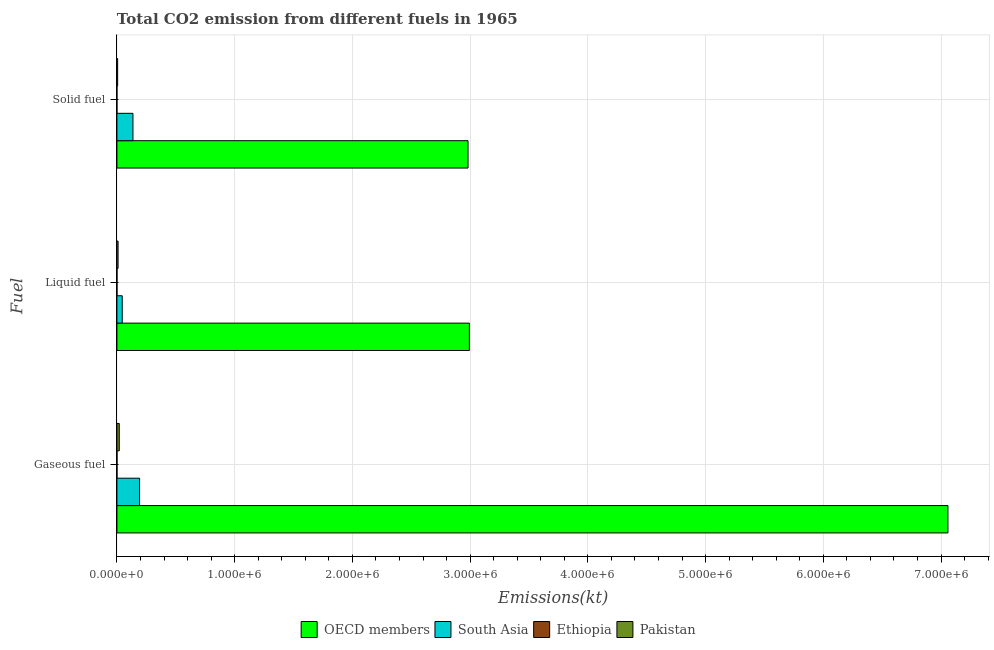How many groups of bars are there?
Offer a very short reply. 3. Are the number of bars per tick equal to the number of legend labels?
Provide a short and direct response. Yes. How many bars are there on the 2nd tick from the bottom?
Your response must be concise. 4. What is the label of the 3rd group of bars from the top?
Offer a terse response. Gaseous fuel. What is the amount of co2 emissions from liquid fuel in Pakistan?
Make the answer very short. 9787.22. Across all countries, what is the maximum amount of co2 emissions from liquid fuel?
Give a very brief answer. 2.99e+06. Across all countries, what is the minimum amount of co2 emissions from liquid fuel?
Offer a terse response. 575.72. In which country was the amount of co2 emissions from liquid fuel minimum?
Give a very brief answer. Ethiopia. What is the total amount of co2 emissions from liquid fuel in the graph?
Your response must be concise. 3.05e+06. What is the difference between the amount of co2 emissions from liquid fuel in Pakistan and that in OECD members?
Offer a very short reply. -2.98e+06. What is the difference between the amount of co2 emissions from liquid fuel in South Asia and the amount of co2 emissions from gaseous fuel in Pakistan?
Provide a short and direct response. 2.51e+04. What is the average amount of co2 emissions from solid fuel per country?
Make the answer very short. 7.81e+05. What is the difference between the amount of co2 emissions from gaseous fuel and amount of co2 emissions from liquid fuel in South Asia?
Your response must be concise. 1.48e+05. In how many countries, is the amount of co2 emissions from gaseous fuel greater than 1200000 kt?
Ensure brevity in your answer.  1. What is the ratio of the amount of co2 emissions from gaseous fuel in OECD members to that in Ethiopia?
Keep it short and to the point. 1.09e+04. What is the difference between the highest and the second highest amount of co2 emissions from solid fuel?
Offer a very short reply. 2.85e+06. What is the difference between the highest and the lowest amount of co2 emissions from solid fuel?
Give a very brief answer. 2.98e+06. What does the 1st bar from the top in Gaseous fuel represents?
Give a very brief answer. Pakistan. What does the 3rd bar from the bottom in Solid fuel represents?
Provide a short and direct response. Ethiopia. Is it the case that in every country, the sum of the amount of co2 emissions from gaseous fuel and amount of co2 emissions from liquid fuel is greater than the amount of co2 emissions from solid fuel?
Give a very brief answer. Yes. What is the difference between two consecutive major ticks on the X-axis?
Ensure brevity in your answer.  1.00e+06. Does the graph contain any zero values?
Keep it short and to the point. No. Does the graph contain grids?
Your answer should be very brief. Yes. Where does the legend appear in the graph?
Your answer should be very brief. Bottom center. How many legend labels are there?
Make the answer very short. 4. How are the legend labels stacked?
Your response must be concise. Horizontal. What is the title of the graph?
Your answer should be very brief. Total CO2 emission from different fuels in 1965. Does "Botswana" appear as one of the legend labels in the graph?
Provide a succinct answer. No. What is the label or title of the X-axis?
Provide a short and direct response. Emissions(kt). What is the label or title of the Y-axis?
Make the answer very short. Fuel. What is the Emissions(kt) of OECD members in Gaseous fuel?
Make the answer very short. 7.06e+06. What is the Emissions(kt) of South Asia in Gaseous fuel?
Keep it short and to the point. 1.93e+05. What is the Emissions(kt) in Ethiopia in Gaseous fuel?
Offer a terse response. 645.39. What is the Emissions(kt) in Pakistan in Gaseous fuel?
Keep it short and to the point. 2.00e+04. What is the Emissions(kt) in OECD members in Liquid fuel?
Offer a very short reply. 2.99e+06. What is the Emissions(kt) in South Asia in Liquid fuel?
Your answer should be very brief. 4.50e+04. What is the Emissions(kt) of Ethiopia in Liquid fuel?
Your answer should be compact. 575.72. What is the Emissions(kt) in Pakistan in Liquid fuel?
Ensure brevity in your answer.  9787.22. What is the Emissions(kt) of OECD members in Solid fuel?
Provide a short and direct response. 2.98e+06. What is the Emissions(kt) in South Asia in Solid fuel?
Give a very brief answer. 1.36e+05. What is the Emissions(kt) in Ethiopia in Solid fuel?
Provide a short and direct response. 25.67. What is the Emissions(kt) in Pakistan in Solid fuel?
Provide a succinct answer. 6171.56. Across all Fuel, what is the maximum Emissions(kt) of OECD members?
Offer a very short reply. 7.06e+06. Across all Fuel, what is the maximum Emissions(kt) in South Asia?
Keep it short and to the point. 1.93e+05. Across all Fuel, what is the maximum Emissions(kt) in Ethiopia?
Provide a short and direct response. 645.39. Across all Fuel, what is the maximum Emissions(kt) of Pakistan?
Provide a short and direct response. 2.00e+04. Across all Fuel, what is the minimum Emissions(kt) in OECD members?
Provide a short and direct response. 2.98e+06. Across all Fuel, what is the minimum Emissions(kt) of South Asia?
Offer a terse response. 4.50e+04. Across all Fuel, what is the minimum Emissions(kt) of Ethiopia?
Offer a terse response. 25.67. Across all Fuel, what is the minimum Emissions(kt) of Pakistan?
Provide a succinct answer. 6171.56. What is the total Emissions(kt) of OECD members in the graph?
Offer a terse response. 1.30e+07. What is the total Emissions(kt) of South Asia in the graph?
Your answer should be compact. 3.74e+05. What is the total Emissions(kt) in Ethiopia in the graph?
Ensure brevity in your answer.  1246.78. What is the total Emissions(kt) of Pakistan in the graph?
Your answer should be compact. 3.59e+04. What is the difference between the Emissions(kt) in OECD members in Gaseous fuel and that in Liquid fuel?
Provide a succinct answer. 4.06e+06. What is the difference between the Emissions(kt) in South Asia in Gaseous fuel and that in Liquid fuel?
Your answer should be compact. 1.48e+05. What is the difference between the Emissions(kt) in Ethiopia in Gaseous fuel and that in Liquid fuel?
Make the answer very short. 69.67. What is the difference between the Emissions(kt) of Pakistan in Gaseous fuel and that in Liquid fuel?
Provide a short and direct response. 1.02e+04. What is the difference between the Emissions(kt) of OECD members in Gaseous fuel and that in Solid fuel?
Offer a very short reply. 4.08e+06. What is the difference between the Emissions(kt) in South Asia in Gaseous fuel and that in Solid fuel?
Offer a terse response. 5.63e+04. What is the difference between the Emissions(kt) in Ethiopia in Gaseous fuel and that in Solid fuel?
Your answer should be very brief. 619.72. What is the difference between the Emissions(kt) in Pakistan in Gaseous fuel and that in Solid fuel?
Your response must be concise. 1.38e+04. What is the difference between the Emissions(kt) in OECD members in Liquid fuel and that in Solid fuel?
Offer a very short reply. 1.14e+04. What is the difference between the Emissions(kt) of South Asia in Liquid fuel and that in Solid fuel?
Your answer should be very brief. -9.12e+04. What is the difference between the Emissions(kt) in Ethiopia in Liquid fuel and that in Solid fuel?
Make the answer very short. 550.05. What is the difference between the Emissions(kt) in Pakistan in Liquid fuel and that in Solid fuel?
Your answer should be very brief. 3615.66. What is the difference between the Emissions(kt) in OECD members in Gaseous fuel and the Emissions(kt) in South Asia in Liquid fuel?
Your response must be concise. 7.01e+06. What is the difference between the Emissions(kt) of OECD members in Gaseous fuel and the Emissions(kt) of Ethiopia in Liquid fuel?
Make the answer very short. 7.06e+06. What is the difference between the Emissions(kt) in OECD members in Gaseous fuel and the Emissions(kt) in Pakistan in Liquid fuel?
Keep it short and to the point. 7.05e+06. What is the difference between the Emissions(kt) in South Asia in Gaseous fuel and the Emissions(kt) in Ethiopia in Liquid fuel?
Your answer should be very brief. 1.92e+05. What is the difference between the Emissions(kt) in South Asia in Gaseous fuel and the Emissions(kt) in Pakistan in Liquid fuel?
Keep it short and to the point. 1.83e+05. What is the difference between the Emissions(kt) in Ethiopia in Gaseous fuel and the Emissions(kt) in Pakistan in Liquid fuel?
Offer a terse response. -9141.83. What is the difference between the Emissions(kt) of OECD members in Gaseous fuel and the Emissions(kt) of South Asia in Solid fuel?
Offer a very short reply. 6.92e+06. What is the difference between the Emissions(kt) in OECD members in Gaseous fuel and the Emissions(kt) in Ethiopia in Solid fuel?
Your answer should be compact. 7.06e+06. What is the difference between the Emissions(kt) of OECD members in Gaseous fuel and the Emissions(kt) of Pakistan in Solid fuel?
Your response must be concise. 7.05e+06. What is the difference between the Emissions(kt) of South Asia in Gaseous fuel and the Emissions(kt) of Ethiopia in Solid fuel?
Your answer should be very brief. 1.93e+05. What is the difference between the Emissions(kt) in South Asia in Gaseous fuel and the Emissions(kt) in Pakistan in Solid fuel?
Keep it short and to the point. 1.86e+05. What is the difference between the Emissions(kt) of Ethiopia in Gaseous fuel and the Emissions(kt) of Pakistan in Solid fuel?
Make the answer very short. -5526.17. What is the difference between the Emissions(kt) in OECD members in Liquid fuel and the Emissions(kt) in South Asia in Solid fuel?
Ensure brevity in your answer.  2.86e+06. What is the difference between the Emissions(kt) in OECD members in Liquid fuel and the Emissions(kt) in Ethiopia in Solid fuel?
Your answer should be very brief. 2.99e+06. What is the difference between the Emissions(kt) of OECD members in Liquid fuel and the Emissions(kt) of Pakistan in Solid fuel?
Provide a succinct answer. 2.99e+06. What is the difference between the Emissions(kt) of South Asia in Liquid fuel and the Emissions(kt) of Ethiopia in Solid fuel?
Provide a short and direct response. 4.50e+04. What is the difference between the Emissions(kt) in South Asia in Liquid fuel and the Emissions(kt) in Pakistan in Solid fuel?
Your answer should be compact. 3.89e+04. What is the difference between the Emissions(kt) of Ethiopia in Liquid fuel and the Emissions(kt) of Pakistan in Solid fuel?
Your answer should be compact. -5595.84. What is the average Emissions(kt) of OECD members per Fuel?
Ensure brevity in your answer.  4.34e+06. What is the average Emissions(kt) of South Asia per Fuel?
Your answer should be compact. 1.25e+05. What is the average Emissions(kt) in Ethiopia per Fuel?
Provide a short and direct response. 415.59. What is the average Emissions(kt) of Pakistan per Fuel?
Provide a short and direct response. 1.20e+04. What is the difference between the Emissions(kt) in OECD members and Emissions(kt) in South Asia in Gaseous fuel?
Your answer should be compact. 6.87e+06. What is the difference between the Emissions(kt) of OECD members and Emissions(kt) of Ethiopia in Gaseous fuel?
Provide a succinct answer. 7.06e+06. What is the difference between the Emissions(kt) of OECD members and Emissions(kt) of Pakistan in Gaseous fuel?
Offer a very short reply. 7.04e+06. What is the difference between the Emissions(kt) of South Asia and Emissions(kt) of Ethiopia in Gaseous fuel?
Provide a succinct answer. 1.92e+05. What is the difference between the Emissions(kt) of South Asia and Emissions(kt) of Pakistan in Gaseous fuel?
Provide a succinct answer. 1.73e+05. What is the difference between the Emissions(kt) of Ethiopia and Emissions(kt) of Pakistan in Gaseous fuel?
Give a very brief answer. -1.93e+04. What is the difference between the Emissions(kt) of OECD members and Emissions(kt) of South Asia in Liquid fuel?
Keep it short and to the point. 2.95e+06. What is the difference between the Emissions(kt) of OECD members and Emissions(kt) of Ethiopia in Liquid fuel?
Give a very brief answer. 2.99e+06. What is the difference between the Emissions(kt) of OECD members and Emissions(kt) of Pakistan in Liquid fuel?
Ensure brevity in your answer.  2.98e+06. What is the difference between the Emissions(kt) in South Asia and Emissions(kt) in Ethiopia in Liquid fuel?
Your response must be concise. 4.44e+04. What is the difference between the Emissions(kt) in South Asia and Emissions(kt) in Pakistan in Liquid fuel?
Ensure brevity in your answer.  3.52e+04. What is the difference between the Emissions(kt) in Ethiopia and Emissions(kt) in Pakistan in Liquid fuel?
Provide a succinct answer. -9211.5. What is the difference between the Emissions(kt) of OECD members and Emissions(kt) of South Asia in Solid fuel?
Ensure brevity in your answer.  2.85e+06. What is the difference between the Emissions(kt) of OECD members and Emissions(kt) of Ethiopia in Solid fuel?
Ensure brevity in your answer.  2.98e+06. What is the difference between the Emissions(kt) in OECD members and Emissions(kt) in Pakistan in Solid fuel?
Provide a succinct answer. 2.98e+06. What is the difference between the Emissions(kt) of South Asia and Emissions(kt) of Ethiopia in Solid fuel?
Your response must be concise. 1.36e+05. What is the difference between the Emissions(kt) in South Asia and Emissions(kt) in Pakistan in Solid fuel?
Make the answer very short. 1.30e+05. What is the difference between the Emissions(kt) of Ethiopia and Emissions(kt) of Pakistan in Solid fuel?
Your answer should be compact. -6145.89. What is the ratio of the Emissions(kt) of OECD members in Gaseous fuel to that in Liquid fuel?
Offer a terse response. 2.36. What is the ratio of the Emissions(kt) of South Asia in Gaseous fuel to that in Liquid fuel?
Give a very brief answer. 4.28. What is the ratio of the Emissions(kt) of Ethiopia in Gaseous fuel to that in Liquid fuel?
Provide a succinct answer. 1.12. What is the ratio of the Emissions(kt) of Pakistan in Gaseous fuel to that in Liquid fuel?
Provide a short and direct response. 2.04. What is the ratio of the Emissions(kt) of OECD members in Gaseous fuel to that in Solid fuel?
Keep it short and to the point. 2.37. What is the ratio of the Emissions(kt) of South Asia in Gaseous fuel to that in Solid fuel?
Offer a terse response. 1.41. What is the ratio of the Emissions(kt) of Ethiopia in Gaseous fuel to that in Solid fuel?
Give a very brief answer. 25.14. What is the ratio of the Emissions(kt) in Pakistan in Gaseous fuel to that in Solid fuel?
Make the answer very short. 3.24. What is the ratio of the Emissions(kt) in OECD members in Liquid fuel to that in Solid fuel?
Your answer should be compact. 1. What is the ratio of the Emissions(kt) of South Asia in Liquid fuel to that in Solid fuel?
Your response must be concise. 0.33. What is the ratio of the Emissions(kt) in Ethiopia in Liquid fuel to that in Solid fuel?
Provide a short and direct response. 22.43. What is the ratio of the Emissions(kt) in Pakistan in Liquid fuel to that in Solid fuel?
Ensure brevity in your answer.  1.59. What is the difference between the highest and the second highest Emissions(kt) in OECD members?
Make the answer very short. 4.06e+06. What is the difference between the highest and the second highest Emissions(kt) in South Asia?
Offer a very short reply. 5.63e+04. What is the difference between the highest and the second highest Emissions(kt) of Ethiopia?
Your answer should be compact. 69.67. What is the difference between the highest and the second highest Emissions(kt) of Pakistan?
Provide a short and direct response. 1.02e+04. What is the difference between the highest and the lowest Emissions(kt) of OECD members?
Your response must be concise. 4.08e+06. What is the difference between the highest and the lowest Emissions(kt) in South Asia?
Offer a very short reply. 1.48e+05. What is the difference between the highest and the lowest Emissions(kt) of Ethiopia?
Offer a very short reply. 619.72. What is the difference between the highest and the lowest Emissions(kt) of Pakistan?
Provide a succinct answer. 1.38e+04. 